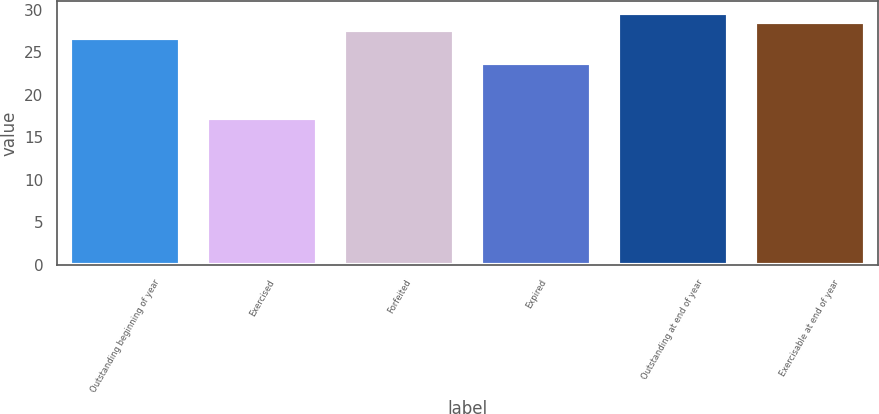<chart> <loc_0><loc_0><loc_500><loc_500><bar_chart><fcel>Outstanding beginning of year<fcel>Exercised<fcel>Forfeited<fcel>Expired<fcel>Outstanding at end of year<fcel>Exercisable at end of year<nl><fcel>26.67<fcel>17.3<fcel>27.63<fcel>23.71<fcel>29.55<fcel>28.59<nl></chart> 